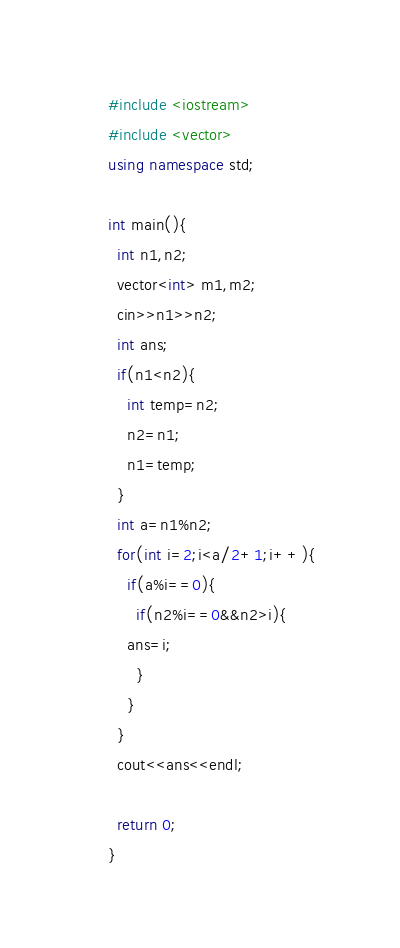Convert code to text. <code><loc_0><loc_0><loc_500><loc_500><_C++_>#include <iostream>
#include <vector>
using namespace std;

int main(){
  int n1,n2;
  vector<int> m1,m2;
  cin>>n1>>n2;
  int ans;
  if(n1<n2){
    int temp=n2;
    n2=n1;
    n1=temp;
  }
  int a=n1%n2;
  for(int i=2;i<a/2+1;i++){
    if(a%i==0){
      if(n2%i==0&&n2>i){
	ans=i;
      }
    }
  }
  cout<<ans<<endl;
  
  return 0;
}</code> 